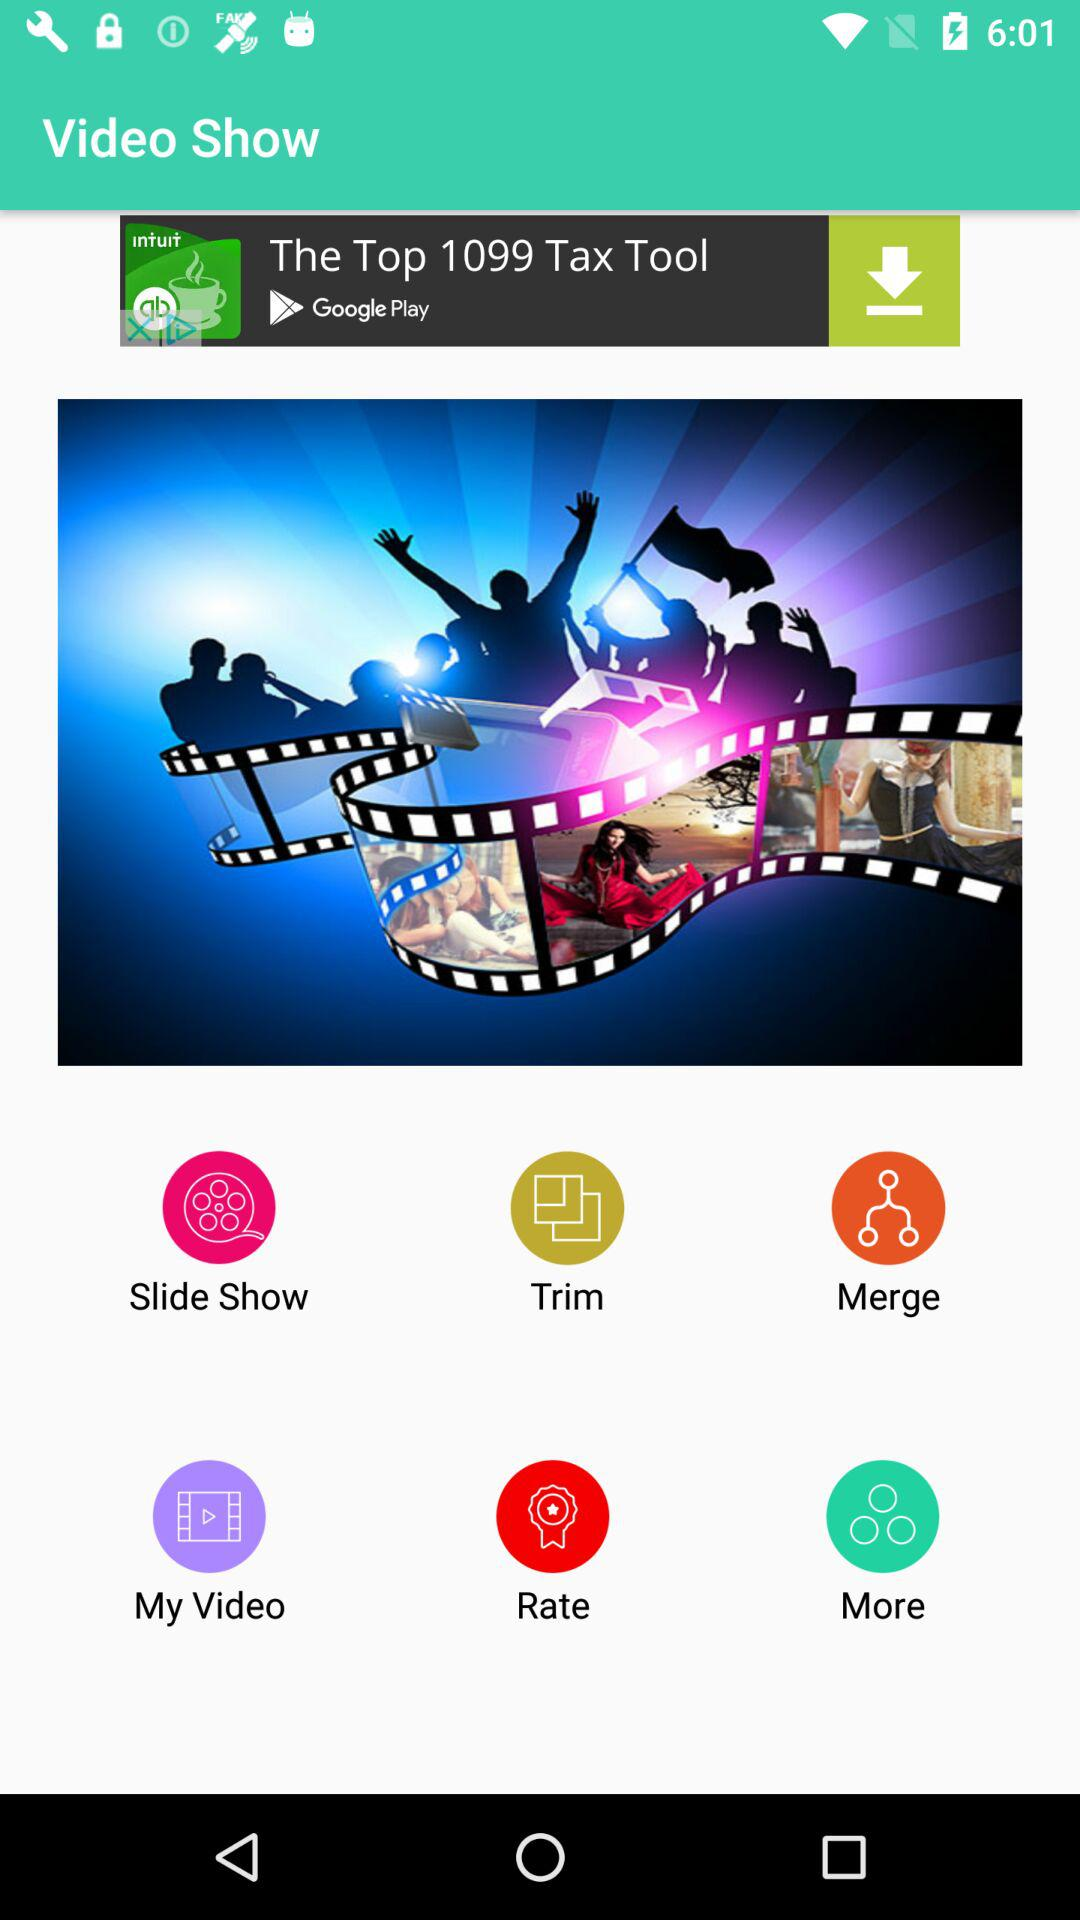When was "Video Show" released?
When the provided information is insufficient, respond with <no answer>. <no answer> 